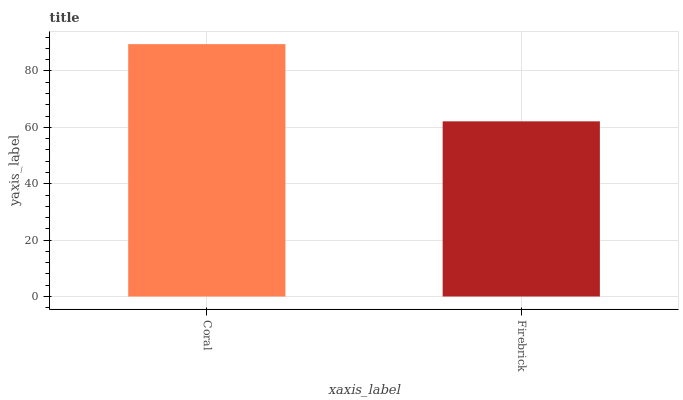Is Firebrick the maximum?
Answer yes or no. No. Is Coral greater than Firebrick?
Answer yes or no. Yes. Is Firebrick less than Coral?
Answer yes or no. Yes. Is Firebrick greater than Coral?
Answer yes or no. No. Is Coral less than Firebrick?
Answer yes or no. No. Is Coral the high median?
Answer yes or no. Yes. Is Firebrick the low median?
Answer yes or no. Yes. Is Firebrick the high median?
Answer yes or no. No. Is Coral the low median?
Answer yes or no. No. 